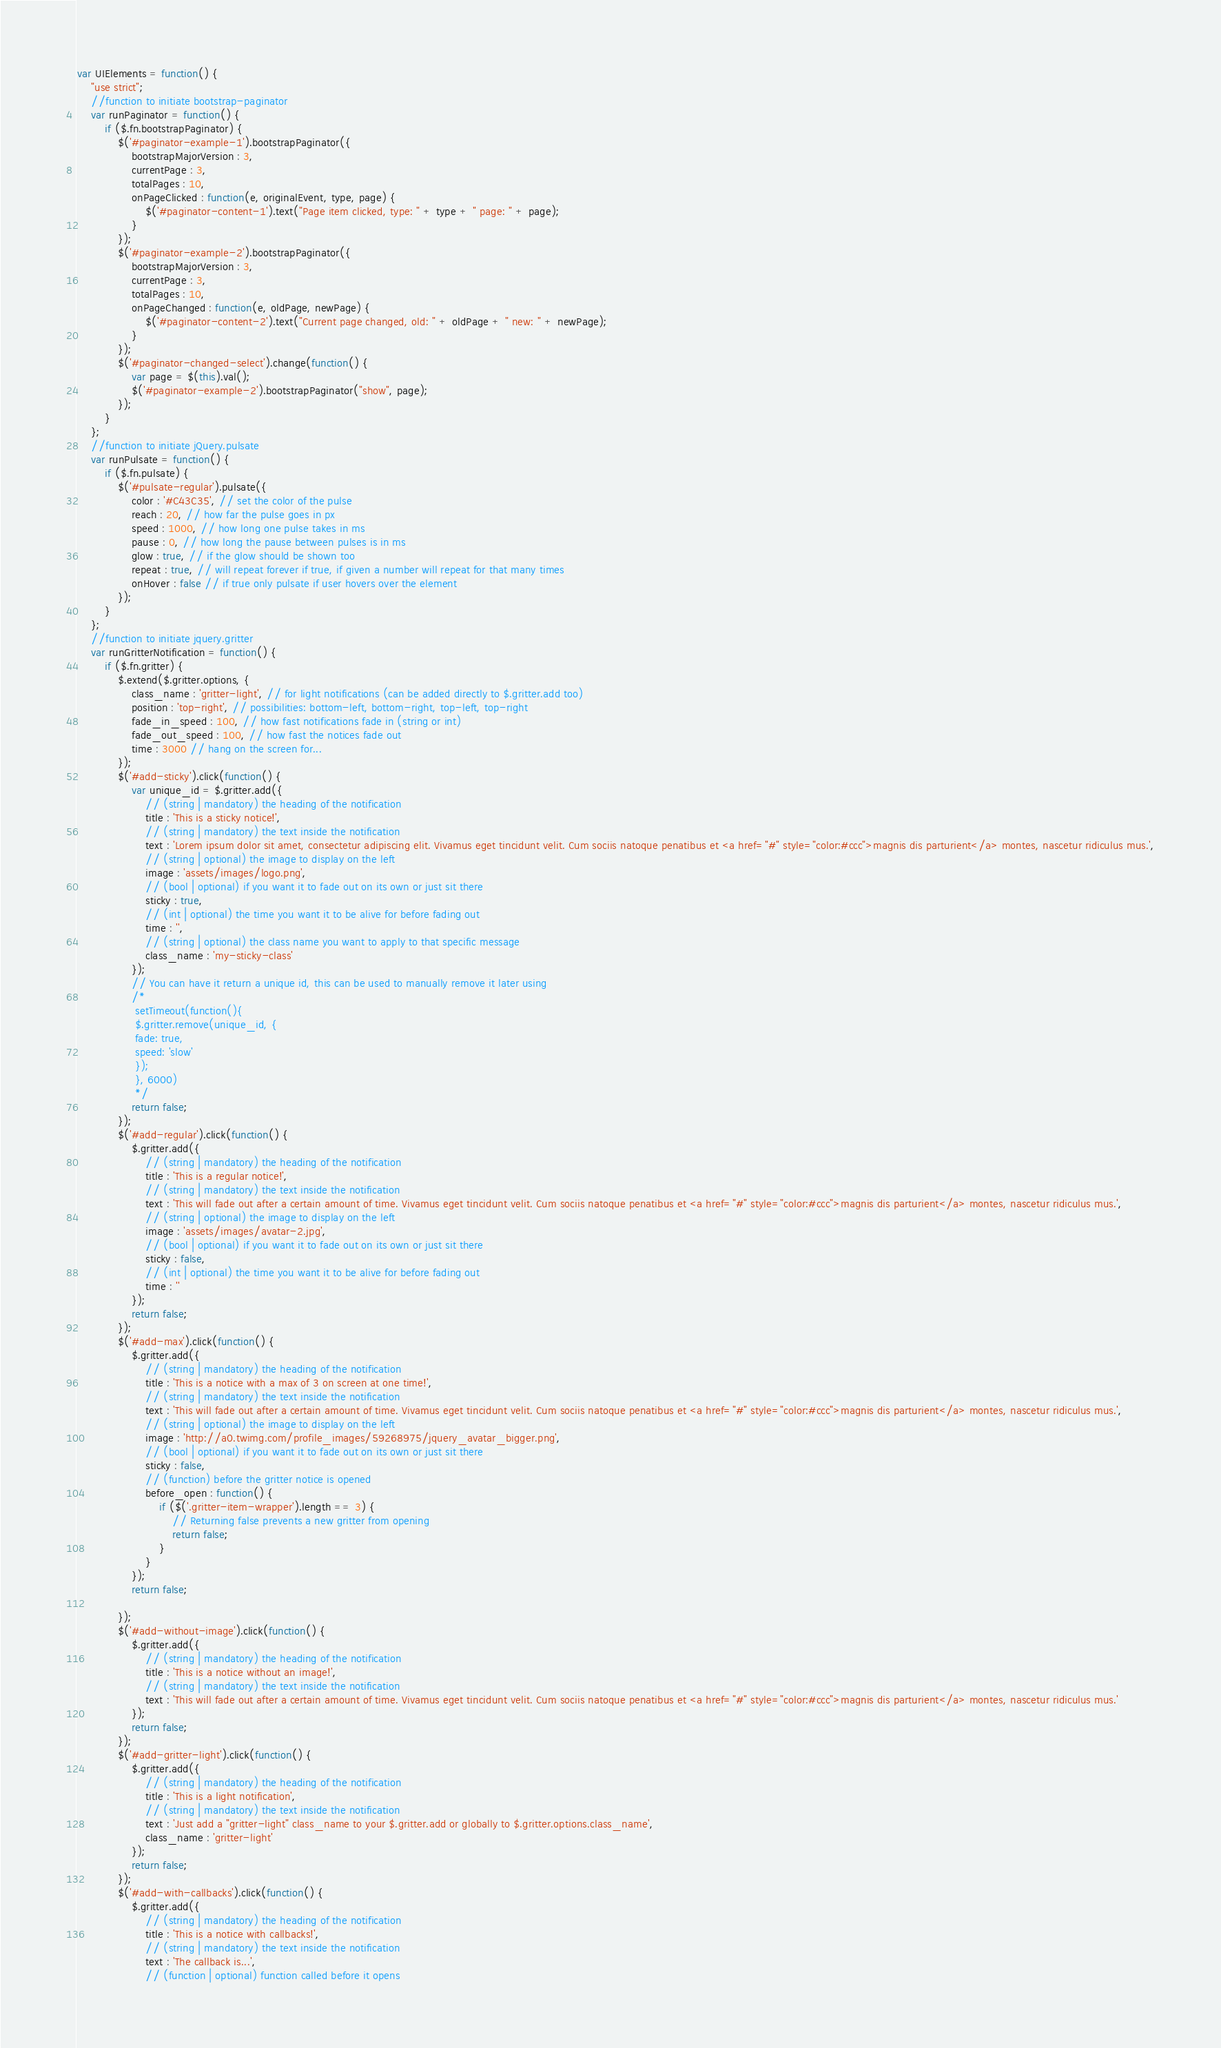Convert code to text. <code><loc_0><loc_0><loc_500><loc_500><_JavaScript_>var UIElements = function() {
	"use strict";
	//function to initiate bootstrap-paginator
	var runPaginator = function() {
		if ($.fn.bootstrapPaginator) {
			$('#paginator-example-1').bootstrapPaginator({
				bootstrapMajorVersion : 3,
				currentPage : 3,
				totalPages : 10,
				onPageClicked : function(e, originalEvent, type, page) {
					$('#paginator-content-1').text("Page item clicked, type: " + type + " page: " + page);
				}
			});
			$('#paginator-example-2').bootstrapPaginator({
				bootstrapMajorVersion : 3,
				currentPage : 3,
				totalPages : 10,
				onPageChanged : function(e, oldPage, newPage) {
					$('#paginator-content-2').text("Current page changed, old: " + oldPage + " new: " + newPage);
				}
			});
			$('#paginator-changed-select').change(function() {
				var page = $(this).val();
				$('#paginator-example-2').bootstrapPaginator("show", page);
			});
		}
	};
	//function to initiate jQuery.pulsate
	var runPulsate = function() {
		if ($.fn.pulsate) {
			$('#pulsate-regular').pulsate({
				color : '#C43C35', // set the color of the pulse
				reach : 20, // how far the pulse goes in px
				speed : 1000, // how long one pulse takes in ms
				pause : 0, // how long the pause between pulses is in ms
				glow : true, // if the glow should be shown too
				repeat : true, // will repeat forever if true, if given a number will repeat for that many times
				onHover : false // if true only pulsate if user hovers over the element
			});
		}
	};
	//function to initiate jquery.gritter
	var runGritterNotification = function() {
		if ($.fn.gritter) {
			$.extend($.gritter.options, {
				class_name : 'gritter-light', // for light notifications (can be added directly to $.gritter.add too)
				position : 'top-right', // possibilities: bottom-left, bottom-right, top-left, top-right
				fade_in_speed : 100, // how fast notifications fade in (string or int)
				fade_out_speed : 100, // how fast the notices fade out
				time : 3000 // hang on the screen for...
			});
			$('#add-sticky').click(function() {
				var unique_id = $.gritter.add({
					// (string | mandatory) the heading of the notification
					title : 'This is a sticky notice!',
					// (string | mandatory) the text inside the notification
					text : 'Lorem ipsum dolor sit amet, consectetur adipiscing elit. Vivamus eget tincidunt velit. Cum sociis natoque penatibus et <a href="#" style="color:#ccc">magnis dis parturient</a> montes, nascetur ridiculus mus.',
					// (string | optional) the image to display on the left
					image : 'assets/images/logo.png',
					// (bool | optional) if you want it to fade out on its own or just sit there
					sticky : true,
					// (int | optional) the time you want it to be alive for before fading out
					time : '',
					// (string | optional) the class name you want to apply to that specific message
					class_name : 'my-sticky-class'
				});
				// You can have it return a unique id, this can be used to manually remove it later using
				/*
				 setTimeout(function(){
				 $.gritter.remove(unique_id, {
				 fade: true,
				 speed: 'slow'
				 });
				 }, 6000)
				 */
				return false;
			});
			$('#add-regular').click(function() {
				$.gritter.add({
					// (string | mandatory) the heading of the notification
					title : 'This is a regular notice!',
					// (string | mandatory) the text inside the notification
					text : 'This will fade out after a certain amount of time. Vivamus eget tincidunt velit. Cum sociis natoque penatibus et <a href="#" style="color:#ccc">magnis dis parturient</a> montes, nascetur ridiculus mus.',
					// (string | optional) the image to display on the left
					image : 'assets/images/avatar-2.jpg',
					// (bool | optional) if you want it to fade out on its own or just sit there
					sticky : false,
					// (int | optional) the time you want it to be alive for before fading out
					time : ''
				});
				return false;
			});
			$('#add-max').click(function() {
				$.gritter.add({
					// (string | mandatory) the heading of the notification
					title : 'This is a notice with a max of 3 on screen at one time!',
					// (string | mandatory) the text inside the notification
					text : 'This will fade out after a certain amount of time. Vivamus eget tincidunt velit. Cum sociis natoque penatibus et <a href="#" style="color:#ccc">magnis dis parturient</a> montes, nascetur ridiculus mus.',
					// (string | optional) the image to display on the left
					image : 'http://a0.twimg.com/profile_images/59268975/jquery_avatar_bigger.png',
					// (bool | optional) if you want it to fade out on its own or just sit there
					sticky : false,
					// (function) before the gritter notice is opened
					before_open : function() {
						if ($('.gritter-item-wrapper').length == 3) {
							// Returning false prevents a new gritter from opening
							return false;
						}
					}
				});
				return false;

			});
			$('#add-without-image').click(function() {
				$.gritter.add({
					// (string | mandatory) the heading of the notification
					title : 'This is a notice without an image!',
					// (string | mandatory) the text inside the notification
					text : 'This will fade out after a certain amount of time. Vivamus eget tincidunt velit. Cum sociis natoque penatibus et <a href="#" style="color:#ccc">magnis dis parturient</a> montes, nascetur ridiculus mus.'
				});
				return false;
			});
			$('#add-gritter-light').click(function() {
				$.gritter.add({
					// (string | mandatory) the heading of the notification
					title : 'This is a light notification',
					// (string | mandatory) the text inside the notification
					text : 'Just add a "gritter-light" class_name to your $.gritter.add or globally to $.gritter.options.class_name',
					class_name : 'gritter-light'
				});
				return false;
			});
			$('#add-with-callbacks').click(function() {
				$.gritter.add({
					// (string | mandatory) the heading of the notification
					title : 'This is a notice with callbacks!',
					// (string | mandatory) the text inside the notification
					text : 'The callback is...',
					// (function | optional) function called before it opens</code> 